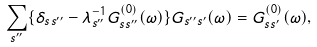Convert formula to latex. <formula><loc_0><loc_0><loc_500><loc_500>\sum _ { s ^ { { \prime } { \prime } } } \{ { \delta } _ { s s ^ { { \prime } { \prime } } } - { \lambda } ^ { - 1 } _ { s ^ { { \prime } { \prime } } } G ^ { ( 0 ) } _ { s s ^ { { \prime } { \prime } } } ( { \omega } ) \} G _ { s ^ { { \prime } { \prime } } s ^ { \prime } } ( { \omega } ) = G ^ { ( 0 ) } _ { s s ^ { \prime } } ( { \omega } ) ,</formula> 